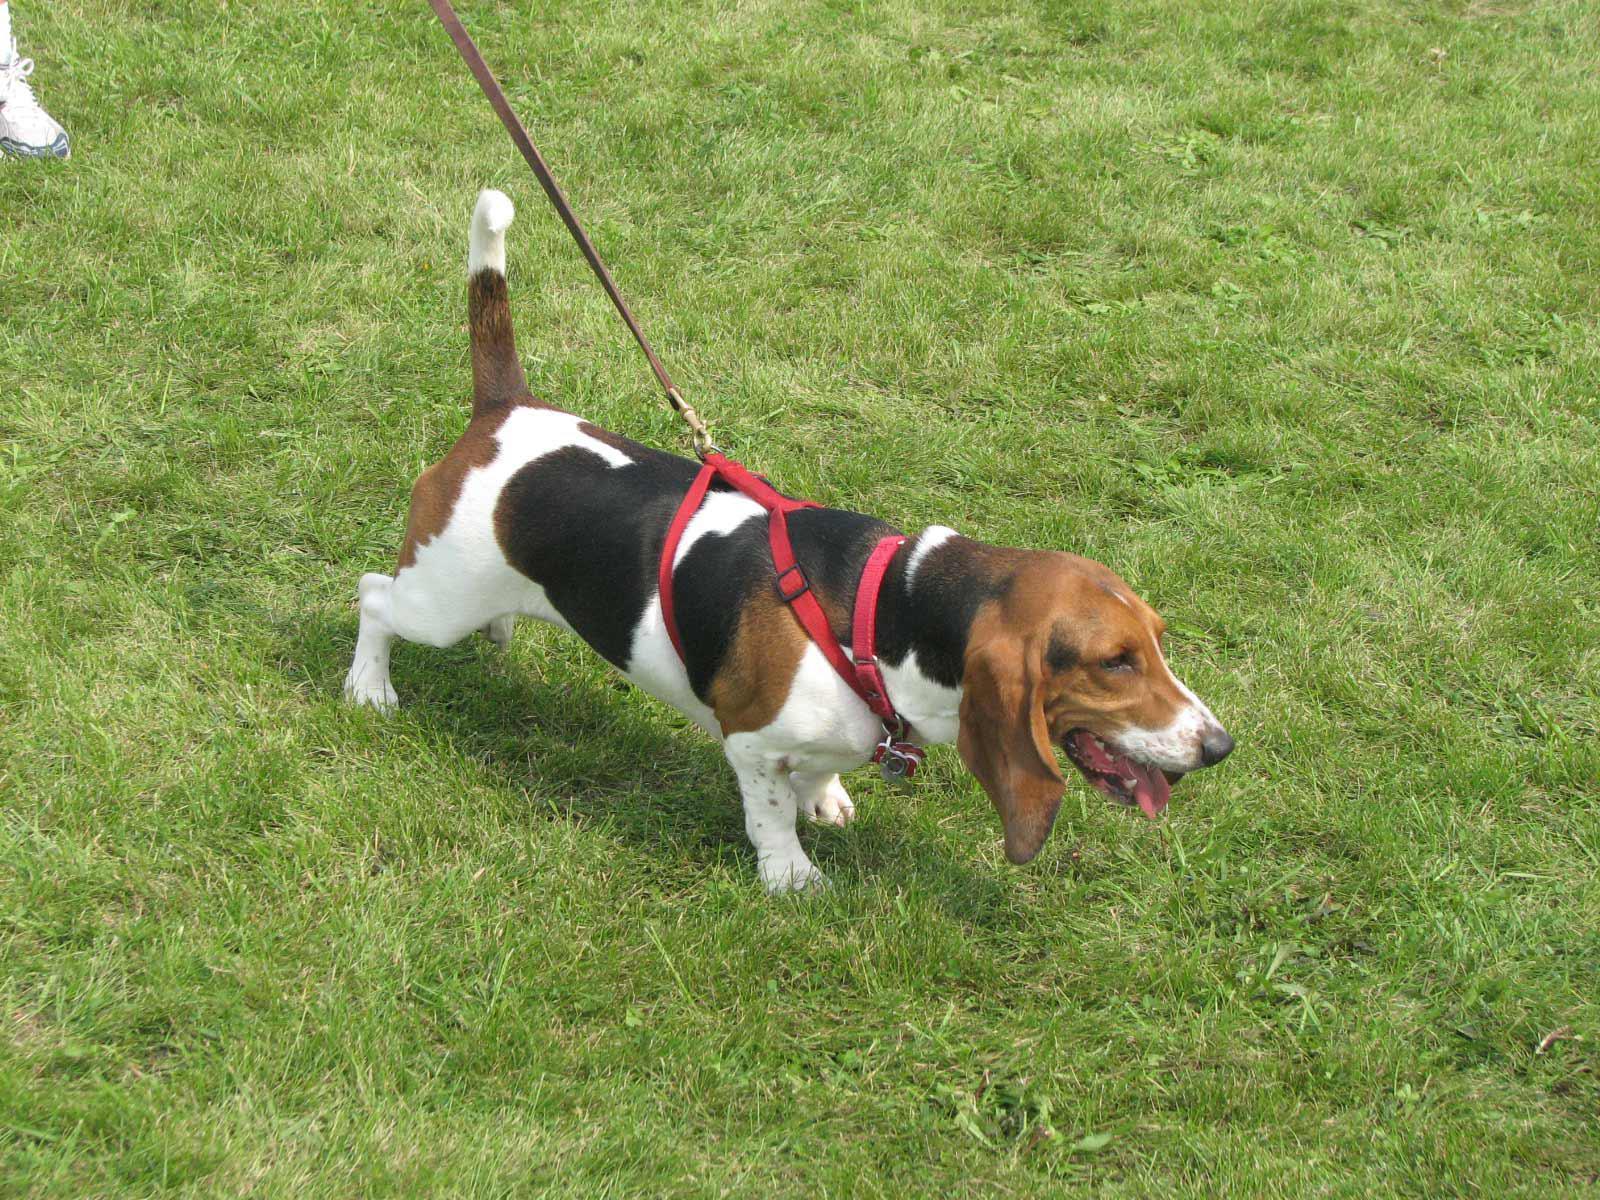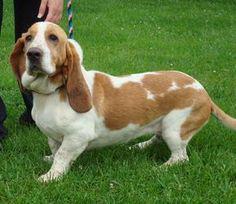The first image is the image on the left, the second image is the image on the right. Evaluate the accuracy of this statement regarding the images: "The dog in the image on the right is standing on the grass.". Is it true? Answer yes or no. Yes. The first image is the image on the left, the second image is the image on the right. For the images displayed, is the sentence "One image shows a basset hound standing on all fours in profile, and the other image shows a basset hound viewed head on." factually correct? Answer yes or no. No. 